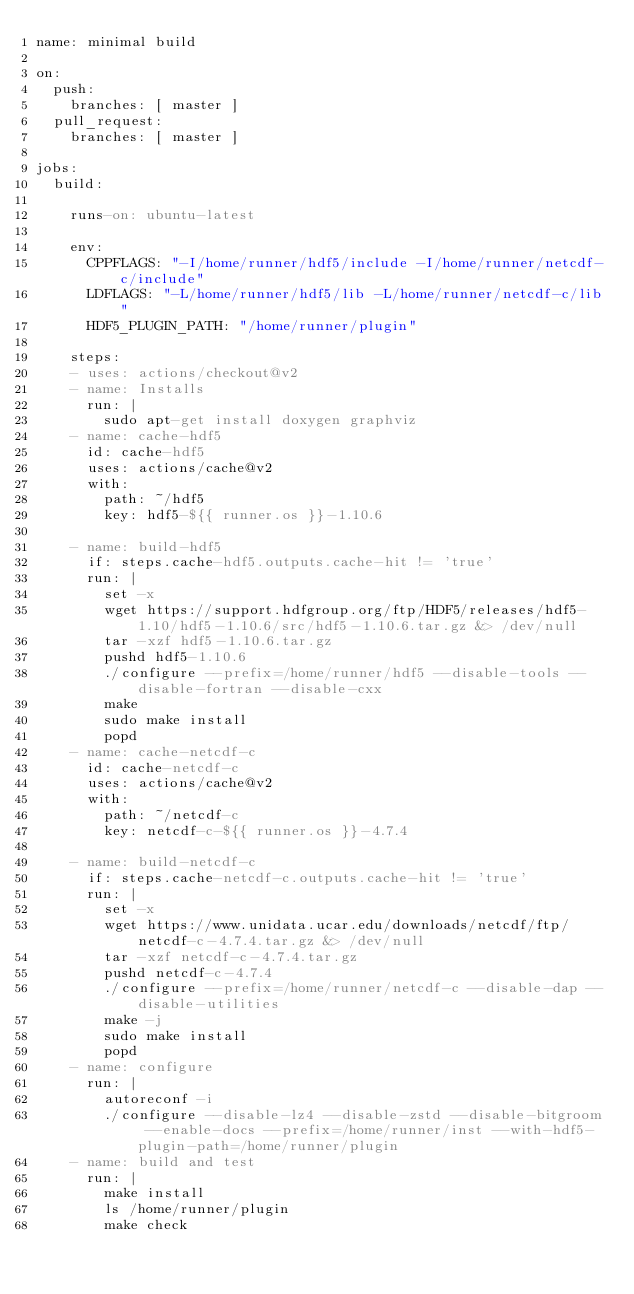<code> <loc_0><loc_0><loc_500><loc_500><_YAML_>name: minimal build

on:
  push:
    branches: [ master ]
  pull_request:
    branches: [ master ]

jobs:
  build:

    runs-on: ubuntu-latest

    env:
      CPPFLAGS: "-I/home/runner/hdf5/include -I/home/runner/netcdf-c/include"
      LDFLAGS: "-L/home/runner/hdf5/lib -L/home/runner/netcdf-c/lib"
      HDF5_PLUGIN_PATH: "/home/runner/plugin"
        
    steps:
    - uses: actions/checkout@v2
    - name: Installs
      run: |
        sudo apt-get install doxygen graphviz
    - name: cache-hdf5
      id: cache-hdf5
      uses: actions/cache@v2
      with:
        path: ~/hdf5
        key: hdf5-${{ runner.os }}-1.10.6

    - name: build-hdf5
      if: steps.cache-hdf5.outputs.cache-hit != 'true'
      run: |
        set -x
        wget https://support.hdfgroup.org/ftp/HDF5/releases/hdf5-1.10/hdf5-1.10.6/src/hdf5-1.10.6.tar.gz &> /dev/null
        tar -xzf hdf5-1.10.6.tar.gz
        pushd hdf5-1.10.6
        ./configure --prefix=/home/runner/hdf5 --disable-tools --disable-fortran --disable-cxx 
        make
        sudo make install
        popd
    - name: cache-netcdf-c
      id: cache-netcdf-c
      uses: actions/cache@v2
      with:
        path: ~/netcdf-c
        key: netcdf-c-${{ runner.os }}-4.7.4

    - name: build-netcdf-c
      if: steps.cache-netcdf-c.outputs.cache-hit != 'true'
      run: |
        set -x
        wget https://www.unidata.ucar.edu/downloads/netcdf/ftp/netcdf-c-4.7.4.tar.gz &> /dev/null
        tar -xzf netcdf-c-4.7.4.tar.gz
        pushd netcdf-c-4.7.4
        ./configure --prefix=/home/runner/netcdf-c --disable-dap --disable-utilities
        make -j
        sudo make install
        popd
    - name: configure
      run: |
        autoreconf -i
        ./configure --disable-lz4 --disable-zstd --disable-bitgroom --enable-docs --prefix=/home/runner/inst --with-hdf5-plugin-path=/home/runner/plugin
    - name: build and test
      run: |
        make install
        ls /home/runner/plugin
        make check
</code> 